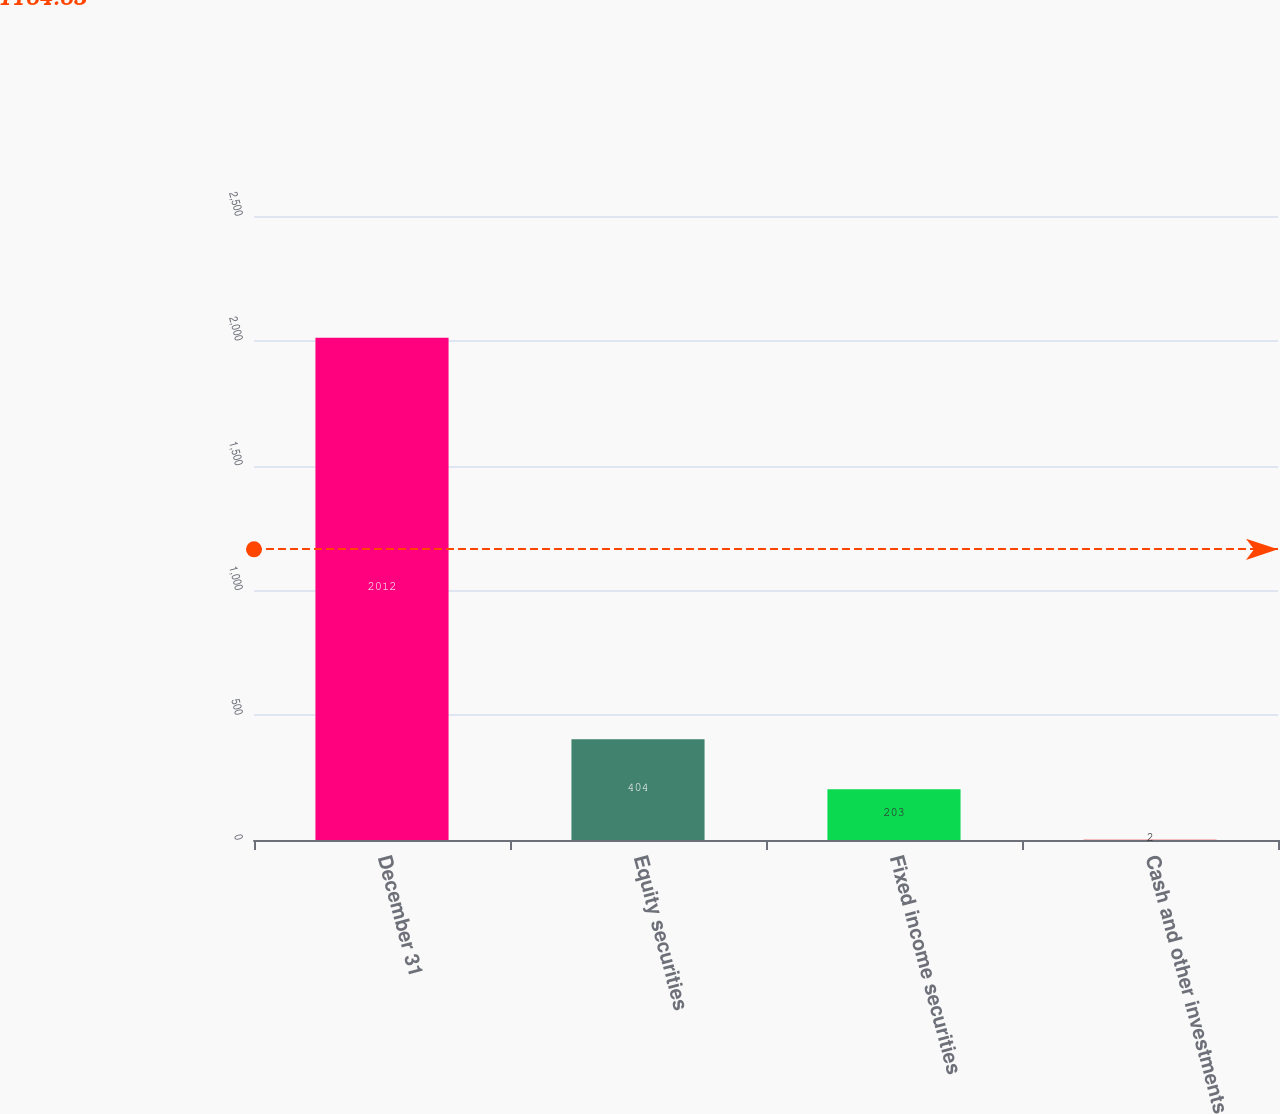<chart> <loc_0><loc_0><loc_500><loc_500><bar_chart><fcel>December 31<fcel>Equity securities<fcel>Fixed income securities<fcel>Cash and other investments<nl><fcel>2012<fcel>404<fcel>203<fcel>2<nl></chart> 